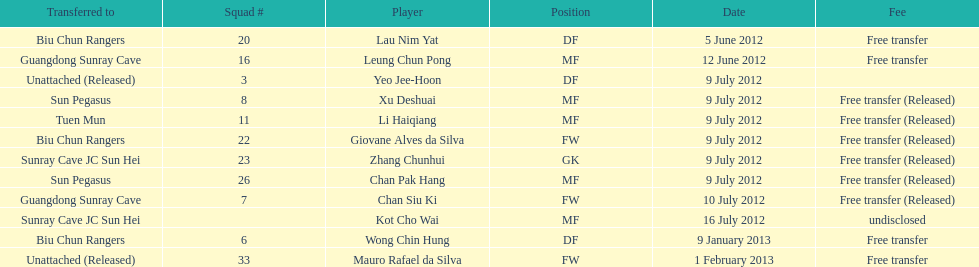Player transferred immediately before mauro rafael da silva Wong Chin Hung. 